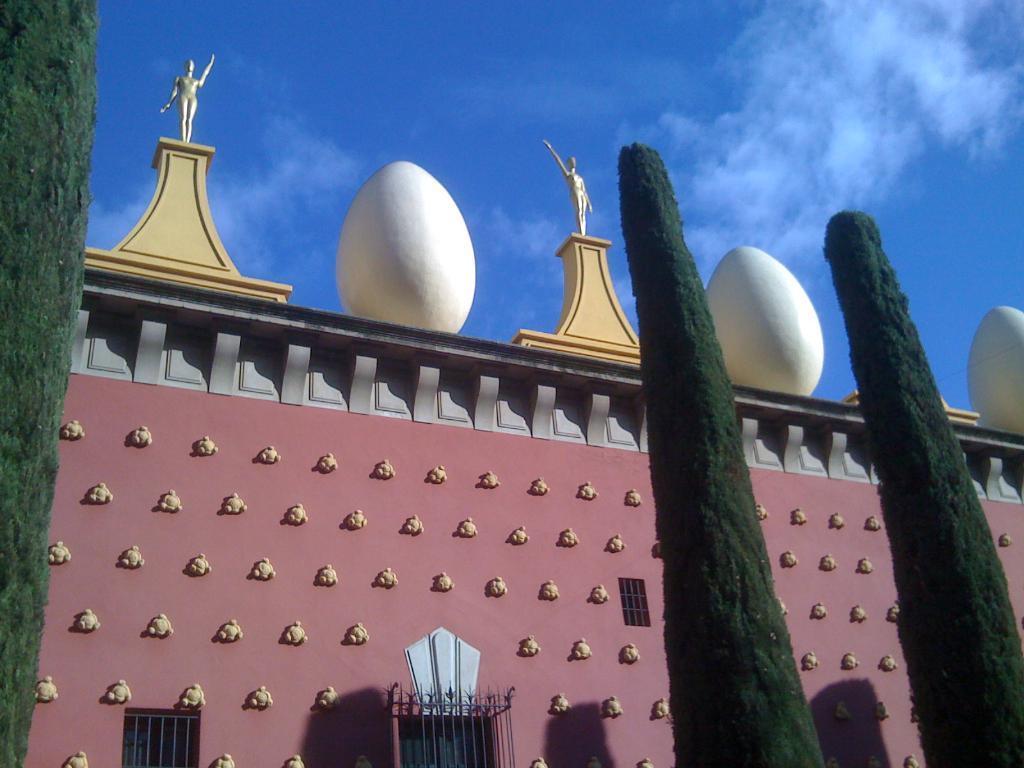In one or two sentences, can you explain what this image depicts? In this image there is a big building with some sculptures on the top, in front of that there are some trees. 